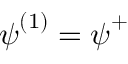<formula> <loc_0><loc_0><loc_500><loc_500>{ \psi } ^ { ( 1 ) } = { \psi } ^ { + }</formula> 